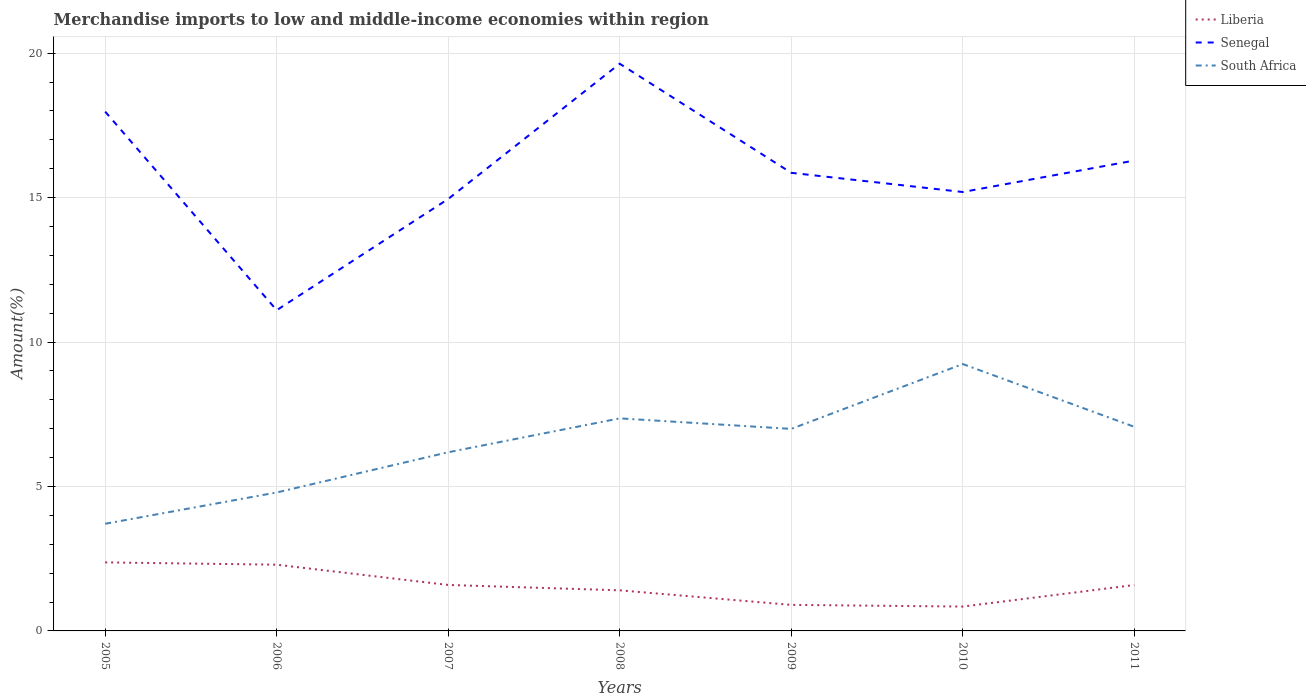Does the line corresponding to South Africa intersect with the line corresponding to Senegal?
Your response must be concise. No. Across all years, what is the maximum percentage of amount earned from merchandise imports in Liberia?
Your response must be concise. 0.84. In which year was the percentage of amount earned from merchandise imports in Liberia maximum?
Your answer should be very brief. 2010. What is the total percentage of amount earned from merchandise imports in South Africa in the graph?
Give a very brief answer. 0.36. What is the difference between the highest and the second highest percentage of amount earned from merchandise imports in Liberia?
Ensure brevity in your answer.  1.53. Is the percentage of amount earned from merchandise imports in South Africa strictly greater than the percentage of amount earned from merchandise imports in Senegal over the years?
Provide a short and direct response. Yes. How many lines are there?
Provide a succinct answer. 3. How many years are there in the graph?
Keep it short and to the point. 7. What is the difference between two consecutive major ticks on the Y-axis?
Your answer should be very brief. 5. Are the values on the major ticks of Y-axis written in scientific E-notation?
Offer a very short reply. No. How are the legend labels stacked?
Offer a very short reply. Vertical. What is the title of the graph?
Ensure brevity in your answer.  Merchandise imports to low and middle-income economies within region. Does "Pacific island small states" appear as one of the legend labels in the graph?
Your response must be concise. No. What is the label or title of the Y-axis?
Offer a terse response. Amount(%). What is the Amount(%) in Liberia in 2005?
Offer a terse response. 2.37. What is the Amount(%) in Senegal in 2005?
Keep it short and to the point. 17.98. What is the Amount(%) of South Africa in 2005?
Make the answer very short. 3.71. What is the Amount(%) in Liberia in 2006?
Ensure brevity in your answer.  2.29. What is the Amount(%) in Senegal in 2006?
Make the answer very short. 11.1. What is the Amount(%) of South Africa in 2006?
Keep it short and to the point. 4.79. What is the Amount(%) of Liberia in 2007?
Offer a very short reply. 1.59. What is the Amount(%) in Senegal in 2007?
Provide a short and direct response. 14.95. What is the Amount(%) of South Africa in 2007?
Make the answer very short. 6.19. What is the Amount(%) of Liberia in 2008?
Offer a very short reply. 1.41. What is the Amount(%) of Senegal in 2008?
Offer a terse response. 19.64. What is the Amount(%) in South Africa in 2008?
Offer a very short reply. 7.36. What is the Amount(%) in Liberia in 2009?
Your response must be concise. 0.9. What is the Amount(%) in Senegal in 2009?
Give a very brief answer. 15.86. What is the Amount(%) in South Africa in 2009?
Your answer should be very brief. 6.99. What is the Amount(%) in Liberia in 2010?
Make the answer very short. 0.84. What is the Amount(%) in Senegal in 2010?
Provide a short and direct response. 15.19. What is the Amount(%) in South Africa in 2010?
Provide a succinct answer. 9.24. What is the Amount(%) in Liberia in 2011?
Your response must be concise. 1.59. What is the Amount(%) in Senegal in 2011?
Keep it short and to the point. 16.28. What is the Amount(%) in South Africa in 2011?
Keep it short and to the point. 7.07. Across all years, what is the maximum Amount(%) in Liberia?
Offer a terse response. 2.37. Across all years, what is the maximum Amount(%) in Senegal?
Your response must be concise. 19.64. Across all years, what is the maximum Amount(%) of South Africa?
Ensure brevity in your answer.  9.24. Across all years, what is the minimum Amount(%) of Liberia?
Your response must be concise. 0.84. Across all years, what is the minimum Amount(%) in Senegal?
Offer a very short reply. 11.1. Across all years, what is the minimum Amount(%) of South Africa?
Provide a short and direct response. 3.71. What is the total Amount(%) of Liberia in the graph?
Ensure brevity in your answer.  11. What is the total Amount(%) in Senegal in the graph?
Ensure brevity in your answer.  111.01. What is the total Amount(%) in South Africa in the graph?
Make the answer very short. 45.35. What is the difference between the Amount(%) of Liberia in 2005 and that in 2006?
Offer a very short reply. 0.08. What is the difference between the Amount(%) in Senegal in 2005 and that in 2006?
Provide a succinct answer. 6.88. What is the difference between the Amount(%) in South Africa in 2005 and that in 2006?
Offer a terse response. -1.08. What is the difference between the Amount(%) of Liberia in 2005 and that in 2007?
Ensure brevity in your answer.  0.78. What is the difference between the Amount(%) of Senegal in 2005 and that in 2007?
Provide a succinct answer. 3.02. What is the difference between the Amount(%) of South Africa in 2005 and that in 2007?
Give a very brief answer. -2.48. What is the difference between the Amount(%) in Liberia in 2005 and that in 2008?
Give a very brief answer. 0.97. What is the difference between the Amount(%) of Senegal in 2005 and that in 2008?
Make the answer very short. -1.66. What is the difference between the Amount(%) of South Africa in 2005 and that in 2008?
Your answer should be compact. -3.65. What is the difference between the Amount(%) in Liberia in 2005 and that in 2009?
Ensure brevity in your answer.  1.47. What is the difference between the Amount(%) of Senegal in 2005 and that in 2009?
Offer a very short reply. 2.12. What is the difference between the Amount(%) of South Africa in 2005 and that in 2009?
Offer a very short reply. -3.28. What is the difference between the Amount(%) in Liberia in 2005 and that in 2010?
Ensure brevity in your answer.  1.53. What is the difference between the Amount(%) of Senegal in 2005 and that in 2010?
Offer a terse response. 2.78. What is the difference between the Amount(%) of South Africa in 2005 and that in 2010?
Ensure brevity in your answer.  -5.53. What is the difference between the Amount(%) in Liberia in 2005 and that in 2011?
Offer a very short reply. 0.78. What is the difference between the Amount(%) in Senegal in 2005 and that in 2011?
Your response must be concise. 1.69. What is the difference between the Amount(%) in South Africa in 2005 and that in 2011?
Give a very brief answer. -3.36. What is the difference between the Amount(%) in Liberia in 2006 and that in 2007?
Provide a succinct answer. 0.7. What is the difference between the Amount(%) of Senegal in 2006 and that in 2007?
Give a very brief answer. -3.85. What is the difference between the Amount(%) of South Africa in 2006 and that in 2007?
Keep it short and to the point. -1.39. What is the difference between the Amount(%) of Liberia in 2006 and that in 2008?
Your answer should be compact. 0.89. What is the difference between the Amount(%) in Senegal in 2006 and that in 2008?
Offer a very short reply. -8.53. What is the difference between the Amount(%) of South Africa in 2006 and that in 2008?
Your answer should be compact. -2.57. What is the difference between the Amount(%) of Liberia in 2006 and that in 2009?
Your answer should be very brief. 1.39. What is the difference between the Amount(%) in Senegal in 2006 and that in 2009?
Make the answer very short. -4.76. What is the difference between the Amount(%) of South Africa in 2006 and that in 2009?
Ensure brevity in your answer.  -2.2. What is the difference between the Amount(%) in Liberia in 2006 and that in 2010?
Offer a terse response. 1.45. What is the difference between the Amount(%) of Senegal in 2006 and that in 2010?
Offer a terse response. -4.09. What is the difference between the Amount(%) of South Africa in 2006 and that in 2010?
Make the answer very short. -4.45. What is the difference between the Amount(%) of Liberia in 2006 and that in 2011?
Give a very brief answer. 0.7. What is the difference between the Amount(%) of Senegal in 2006 and that in 2011?
Your answer should be very brief. -5.18. What is the difference between the Amount(%) in South Africa in 2006 and that in 2011?
Your answer should be very brief. -2.27. What is the difference between the Amount(%) in Liberia in 2007 and that in 2008?
Ensure brevity in your answer.  0.19. What is the difference between the Amount(%) in Senegal in 2007 and that in 2008?
Ensure brevity in your answer.  -4.68. What is the difference between the Amount(%) of South Africa in 2007 and that in 2008?
Keep it short and to the point. -1.17. What is the difference between the Amount(%) in Liberia in 2007 and that in 2009?
Offer a very short reply. 0.69. What is the difference between the Amount(%) of Senegal in 2007 and that in 2009?
Give a very brief answer. -0.91. What is the difference between the Amount(%) in South Africa in 2007 and that in 2009?
Ensure brevity in your answer.  -0.81. What is the difference between the Amount(%) in Liberia in 2007 and that in 2010?
Ensure brevity in your answer.  0.75. What is the difference between the Amount(%) in Senegal in 2007 and that in 2010?
Provide a short and direct response. -0.24. What is the difference between the Amount(%) of South Africa in 2007 and that in 2010?
Your answer should be compact. -3.05. What is the difference between the Amount(%) in Liberia in 2007 and that in 2011?
Your response must be concise. 0. What is the difference between the Amount(%) of Senegal in 2007 and that in 2011?
Your answer should be compact. -1.33. What is the difference between the Amount(%) in South Africa in 2007 and that in 2011?
Your response must be concise. -0.88. What is the difference between the Amount(%) of Liberia in 2008 and that in 2009?
Provide a short and direct response. 0.5. What is the difference between the Amount(%) of Senegal in 2008 and that in 2009?
Offer a terse response. 3.78. What is the difference between the Amount(%) of South Africa in 2008 and that in 2009?
Your answer should be very brief. 0.36. What is the difference between the Amount(%) in Liberia in 2008 and that in 2010?
Offer a very short reply. 0.56. What is the difference between the Amount(%) in Senegal in 2008 and that in 2010?
Offer a very short reply. 4.44. What is the difference between the Amount(%) in South Africa in 2008 and that in 2010?
Give a very brief answer. -1.88. What is the difference between the Amount(%) of Liberia in 2008 and that in 2011?
Keep it short and to the point. -0.18. What is the difference between the Amount(%) in Senegal in 2008 and that in 2011?
Give a very brief answer. 3.35. What is the difference between the Amount(%) in South Africa in 2008 and that in 2011?
Your response must be concise. 0.29. What is the difference between the Amount(%) of Liberia in 2009 and that in 2010?
Keep it short and to the point. 0.06. What is the difference between the Amount(%) in Senegal in 2009 and that in 2010?
Provide a succinct answer. 0.66. What is the difference between the Amount(%) in South Africa in 2009 and that in 2010?
Give a very brief answer. -2.25. What is the difference between the Amount(%) of Liberia in 2009 and that in 2011?
Keep it short and to the point. -0.69. What is the difference between the Amount(%) of Senegal in 2009 and that in 2011?
Your answer should be very brief. -0.42. What is the difference between the Amount(%) of South Africa in 2009 and that in 2011?
Make the answer very short. -0.07. What is the difference between the Amount(%) in Liberia in 2010 and that in 2011?
Ensure brevity in your answer.  -0.75. What is the difference between the Amount(%) of Senegal in 2010 and that in 2011?
Offer a terse response. -1.09. What is the difference between the Amount(%) of South Africa in 2010 and that in 2011?
Make the answer very short. 2.17. What is the difference between the Amount(%) of Liberia in 2005 and the Amount(%) of Senegal in 2006?
Your answer should be compact. -8.73. What is the difference between the Amount(%) of Liberia in 2005 and the Amount(%) of South Africa in 2006?
Ensure brevity in your answer.  -2.42. What is the difference between the Amount(%) in Senegal in 2005 and the Amount(%) in South Africa in 2006?
Provide a short and direct response. 13.19. What is the difference between the Amount(%) in Liberia in 2005 and the Amount(%) in Senegal in 2007?
Offer a very short reply. -12.58. What is the difference between the Amount(%) of Liberia in 2005 and the Amount(%) of South Africa in 2007?
Your response must be concise. -3.81. What is the difference between the Amount(%) in Senegal in 2005 and the Amount(%) in South Africa in 2007?
Your answer should be very brief. 11.79. What is the difference between the Amount(%) of Liberia in 2005 and the Amount(%) of Senegal in 2008?
Your response must be concise. -17.26. What is the difference between the Amount(%) in Liberia in 2005 and the Amount(%) in South Africa in 2008?
Your answer should be compact. -4.99. What is the difference between the Amount(%) in Senegal in 2005 and the Amount(%) in South Africa in 2008?
Make the answer very short. 10.62. What is the difference between the Amount(%) in Liberia in 2005 and the Amount(%) in Senegal in 2009?
Your response must be concise. -13.49. What is the difference between the Amount(%) in Liberia in 2005 and the Amount(%) in South Africa in 2009?
Offer a terse response. -4.62. What is the difference between the Amount(%) in Senegal in 2005 and the Amount(%) in South Africa in 2009?
Offer a terse response. 10.98. What is the difference between the Amount(%) of Liberia in 2005 and the Amount(%) of Senegal in 2010?
Make the answer very short. -12.82. What is the difference between the Amount(%) in Liberia in 2005 and the Amount(%) in South Africa in 2010?
Give a very brief answer. -6.87. What is the difference between the Amount(%) in Senegal in 2005 and the Amount(%) in South Africa in 2010?
Provide a succinct answer. 8.74. What is the difference between the Amount(%) of Liberia in 2005 and the Amount(%) of Senegal in 2011?
Make the answer very short. -13.91. What is the difference between the Amount(%) in Liberia in 2005 and the Amount(%) in South Africa in 2011?
Provide a short and direct response. -4.69. What is the difference between the Amount(%) of Senegal in 2005 and the Amount(%) of South Africa in 2011?
Provide a short and direct response. 10.91. What is the difference between the Amount(%) of Liberia in 2006 and the Amount(%) of Senegal in 2007?
Your answer should be very brief. -12.66. What is the difference between the Amount(%) in Liberia in 2006 and the Amount(%) in South Africa in 2007?
Make the answer very short. -3.89. What is the difference between the Amount(%) in Senegal in 2006 and the Amount(%) in South Africa in 2007?
Provide a succinct answer. 4.92. What is the difference between the Amount(%) in Liberia in 2006 and the Amount(%) in Senegal in 2008?
Offer a terse response. -17.34. What is the difference between the Amount(%) in Liberia in 2006 and the Amount(%) in South Africa in 2008?
Provide a short and direct response. -5.07. What is the difference between the Amount(%) in Senegal in 2006 and the Amount(%) in South Africa in 2008?
Offer a very short reply. 3.74. What is the difference between the Amount(%) in Liberia in 2006 and the Amount(%) in Senegal in 2009?
Provide a short and direct response. -13.57. What is the difference between the Amount(%) in Liberia in 2006 and the Amount(%) in South Africa in 2009?
Keep it short and to the point. -4.7. What is the difference between the Amount(%) in Senegal in 2006 and the Amount(%) in South Africa in 2009?
Your answer should be very brief. 4.11. What is the difference between the Amount(%) of Liberia in 2006 and the Amount(%) of Senegal in 2010?
Make the answer very short. -12.9. What is the difference between the Amount(%) in Liberia in 2006 and the Amount(%) in South Africa in 2010?
Ensure brevity in your answer.  -6.95. What is the difference between the Amount(%) of Senegal in 2006 and the Amount(%) of South Africa in 2010?
Keep it short and to the point. 1.86. What is the difference between the Amount(%) of Liberia in 2006 and the Amount(%) of Senegal in 2011?
Give a very brief answer. -13.99. What is the difference between the Amount(%) of Liberia in 2006 and the Amount(%) of South Africa in 2011?
Provide a succinct answer. -4.77. What is the difference between the Amount(%) in Senegal in 2006 and the Amount(%) in South Africa in 2011?
Provide a succinct answer. 4.04. What is the difference between the Amount(%) of Liberia in 2007 and the Amount(%) of Senegal in 2008?
Keep it short and to the point. -18.04. What is the difference between the Amount(%) of Liberia in 2007 and the Amount(%) of South Africa in 2008?
Your answer should be very brief. -5.77. What is the difference between the Amount(%) in Senegal in 2007 and the Amount(%) in South Africa in 2008?
Give a very brief answer. 7.59. What is the difference between the Amount(%) in Liberia in 2007 and the Amount(%) in Senegal in 2009?
Your response must be concise. -14.27. What is the difference between the Amount(%) of Liberia in 2007 and the Amount(%) of South Africa in 2009?
Keep it short and to the point. -5.4. What is the difference between the Amount(%) in Senegal in 2007 and the Amount(%) in South Africa in 2009?
Make the answer very short. 7.96. What is the difference between the Amount(%) of Liberia in 2007 and the Amount(%) of Senegal in 2010?
Your answer should be compact. -13.6. What is the difference between the Amount(%) in Liberia in 2007 and the Amount(%) in South Africa in 2010?
Your answer should be compact. -7.65. What is the difference between the Amount(%) of Senegal in 2007 and the Amount(%) of South Africa in 2010?
Give a very brief answer. 5.71. What is the difference between the Amount(%) of Liberia in 2007 and the Amount(%) of Senegal in 2011?
Give a very brief answer. -14.69. What is the difference between the Amount(%) in Liberia in 2007 and the Amount(%) in South Africa in 2011?
Provide a short and direct response. -5.48. What is the difference between the Amount(%) in Senegal in 2007 and the Amount(%) in South Africa in 2011?
Your answer should be very brief. 7.89. What is the difference between the Amount(%) of Liberia in 2008 and the Amount(%) of Senegal in 2009?
Provide a succinct answer. -14.45. What is the difference between the Amount(%) in Liberia in 2008 and the Amount(%) in South Africa in 2009?
Make the answer very short. -5.59. What is the difference between the Amount(%) of Senegal in 2008 and the Amount(%) of South Africa in 2009?
Offer a very short reply. 12.64. What is the difference between the Amount(%) of Liberia in 2008 and the Amount(%) of Senegal in 2010?
Provide a succinct answer. -13.79. What is the difference between the Amount(%) in Liberia in 2008 and the Amount(%) in South Africa in 2010?
Your answer should be very brief. -7.83. What is the difference between the Amount(%) in Senegal in 2008 and the Amount(%) in South Africa in 2010?
Provide a short and direct response. 10.4. What is the difference between the Amount(%) of Liberia in 2008 and the Amount(%) of Senegal in 2011?
Your answer should be compact. -14.88. What is the difference between the Amount(%) in Liberia in 2008 and the Amount(%) in South Africa in 2011?
Make the answer very short. -5.66. What is the difference between the Amount(%) of Senegal in 2008 and the Amount(%) of South Africa in 2011?
Make the answer very short. 12.57. What is the difference between the Amount(%) in Liberia in 2009 and the Amount(%) in Senegal in 2010?
Keep it short and to the point. -14.29. What is the difference between the Amount(%) of Liberia in 2009 and the Amount(%) of South Africa in 2010?
Provide a short and direct response. -8.34. What is the difference between the Amount(%) of Senegal in 2009 and the Amount(%) of South Africa in 2010?
Ensure brevity in your answer.  6.62. What is the difference between the Amount(%) of Liberia in 2009 and the Amount(%) of Senegal in 2011?
Offer a very short reply. -15.38. What is the difference between the Amount(%) in Liberia in 2009 and the Amount(%) in South Africa in 2011?
Your answer should be very brief. -6.17. What is the difference between the Amount(%) of Senegal in 2009 and the Amount(%) of South Africa in 2011?
Offer a very short reply. 8.79. What is the difference between the Amount(%) of Liberia in 2010 and the Amount(%) of Senegal in 2011?
Offer a very short reply. -15.44. What is the difference between the Amount(%) of Liberia in 2010 and the Amount(%) of South Africa in 2011?
Offer a terse response. -6.22. What is the difference between the Amount(%) in Senegal in 2010 and the Amount(%) in South Africa in 2011?
Offer a terse response. 8.13. What is the average Amount(%) of Liberia per year?
Make the answer very short. 1.57. What is the average Amount(%) of Senegal per year?
Make the answer very short. 15.86. What is the average Amount(%) in South Africa per year?
Your response must be concise. 6.48. In the year 2005, what is the difference between the Amount(%) in Liberia and Amount(%) in Senegal?
Your answer should be very brief. -15.61. In the year 2005, what is the difference between the Amount(%) in Liberia and Amount(%) in South Africa?
Offer a very short reply. -1.34. In the year 2005, what is the difference between the Amount(%) in Senegal and Amount(%) in South Africa?
Offer a very short reply. 14.27. In the year 2006, what is the difference between the Amount(%) of Liberia and Amount(%) of Senegal?
Offer a very short reply. -8.81. In the year 2006, what is the difference between the Amount(%) of Liberia and Amount(%) of South Africa?
Offer a very short reply. -2.5. In the year 2006, what is the difference between the Amount(%) in Senegal and Amount(%) in South Africa?
Your answer should be compact. 6.31. In the year 2007, what is the difference between the Amount(%) of Liberia and Amount(%) of Senegal?
Ensure brevity in your answer.  -13.36. In the year 2007, what is the difference between the Amount(%) in Liberia and Amount(%) in South Africa?
Your response must be concise. -4.59. In the year 2007, what is the difference between the Amount(%) in Senegal and Amount(%) in South Africa?
Provide a succinct answer. 8.77. In the year 2008, what is the difference between the Amount(%) in Liberia and Amount(%) in Senegal?
Offer a very short reply. -18.23. In the year 2008, what is the difference between the Amount(%) in Liberia and Amount(%) in South Africa?
Provide a short and direct response. -5.95. In the year 2008, what is the difference between the Amount(%) in Senegal and Amount(%) in South Africa?
Keep it short and to the point. 12.28. In the year 2009, what is the difference between the Amount(%) of Liberia and Amount(%) of Senegal?
Keep it short and to the point. -14.96. In the year 2009, what is the difference between the Amount(%) in Liberia and Amount(%) in South Africa?
Ensure brevity in your answer.  -6.09. In the year 2009, what is the difference between the Amount(%) in Senegal and Amount(%) in South Africa?
Your answer should be very brief. 8.87. In the year 2010, what is the difference between the Amount(%) in Liberia and Amount(%) in Senegal?
Make the answer very short. -14.35. In the year 2010, what is the difference between the Amount(%) of Liberia and Amount(%) of South Africa?
Your answer should be very brief. -8.4. In the year 2010, what is the difference between the Amount(%) of Senegal and Amount(%) of South Africa?
Keep it short and to the point. 5.96. In the year 2011, what is the difference between the Amount(%) of Liberia and Amount(%) of Senegal?
Your answer should be very brief. -14.69. In the year 2011, what is the difference between the Amount(%) of Liberia and Amount(%) of South Africa?
Make the answer very short. -5.48. In the year 2011, what is the difference between the Amount(%) of Senegal and Amount(%) of South Africa?
Give a very brief answer. 9.22. What is the ratio of the Amount(%) in Liberia in 2005 to that in 2006?
Give a very brief answer. 1.03. What is the ratio of the Amount(%) in Senegal in 2005 to that in 2006?
Give a very brief answer. 1.62. What is the ratio of the Amount(%) of South Africa in 2005 to that in 2006?
Ensure brevity in your answer.  0.77. What is the ratio of the Amount(%) of Liberia in 2005 to that in 2007?
Your answer should be compact. 1.49. What is the ratio of the Amount(%) in Senegal in 2005 to that in 2007?
Your response must be concise. 1.2. What is the ratio of the Amount(%) of South Africa in 2005 to that in 2007?
Give a very brief answer. 0.6. What is the ratio of the Amount(%) in Liberia in 2005 to that in 2008?
Provide a succinct answer. 1.69. What is the ratio of the Amount(%) in Senegal in 2005 to that in 2008?
Offer a very short reply. 0.92. What is the ratio of the Amount(%) in South Africa in 2005 to that in 2008?
Give a very brief answer. 0.5. What is the ratio of the Amount(%) in Liberia in 2005 to that in 2009?
Keep it short and to the point. 2.63. What is the ratio of the Amount(%) in Senegal in 2005 to that in 2009?
Your answer should be compact. 1.13. What is the ratio of the Amount(%) of South Africa in 2005 to that in 2009?
Your answer should be very brief. 0.53. What is the ratio of the Amount(%) in Liberia in 2005 to that in 2010?
Provide a succinct answer. 2.81. What is the ratio of the Amount(%) in Senegal in 2005 to that in 2010?
Keep it short and to the point. 1.18. What is the ratio of the Amount(%) of South Africa in 2005 to that in 2010?
Give a very brief answer. 0.4. What is the ratio of the Amount(%) in Liberia in 2005 to that in 2011?
Your answer should be compact. 1.49. What is the ratio of the Amount(%) of Senegal in 2005 to that in 2011?
Your response must be concise. 1.1. What is the ratio of the Amount(%) in South Africa in 2005 to that in 2011?
Keep it short and to the point. 0.52. What is the ratio of the Amount(%) of Liberia in 2006 to that in 2007?
Make the answer very short. 1.44. What is the ratio of the Amount(%) of Senegal in 2006 to that in 2007?
Offer a terse response. 0.74. What is the ratio of the Amount(%) of South Africa in 2006 to that in 2007?
Provide a succinct answer. 0.77. What is the ratio of the Amount(%) of Liberia in 2006 to that in 2008?
Provide a succinct answer. 1.63. What is the ratio of the Amount(%) in Senegal in 2006 to that in 2008?
Ensure brevity in your answer.  0.57. What is the ratio of the Amount(%) in South Africa in 2006 to that in 2008?
Provide a succinct answer. 0.65. What is the ratio of the Amount(%) in Liberia in 2006 to that in 2009?
Ensure brevity in your answer.  2.54. What is the ratio of the Amount(%) of Senegal in 2006 to that in 2009?
Ensure brevity in your answer.  0.7. What is the ratio of the Amount(%) of South Africa in 2006 to that in 2009?
Ensure brevity in your answer.  0.69. What is the ratio of the Amount(%) in Liberia in 2006 to that in 2010?
Offer a very short reply. 2.72. What is the ratio of the Amount(%) of Senegal in 2006 to that in 2010?
Your answer should be compact. 0.73. What is the ratio of the Amount(%) in South Africa in 2006 to that in 2010?
Provide a succinct answer. 0.52. What is the ratio of the Amount(%) in Liberia in 2006 to that in 2011?
Your response must be concise. 1.44. What is the ratio of the Amount(%) of Senegal in 2006 to that in 2011?
Give a very brief answer. 0.68. What is the ratio of the Amount(%) of South Africa in 2006 to that in 2011?
Offer a very short reply. 0.68. What is the ratio of the Amount(%) in Liberia in 2007 to that in 2008?
Keep it short and to the point. 1.13. What is the ratio of the Amount(%) of Senegal in 2007 to that in 2008?
Offer a very short reply. 0.76. What is the ratio of the Amount(%) of South Africa in 2007 to that in 2008?
Your response must be concise. 0.84. What is the ratio of the Amount(%) in Liberia in 2007 to that in 2009?
Your answer should be compact. 1.76. What is the ratio of the Amount(%) in Senegal in 2007 to that in 2009?
Give a very brief answer. 0.94. What is the ratio of the Amount(%) in South Africa in 2007 to that in 2009?
Offer a terse response. 0.88. What is the ratio of the Amount(%) of Liberia in 2007 to that in 2010?
Your answer should be very brief. 1.89. What is the ratio of the Amount(%) in Senegal in 2007 to that in 2010?
Provide a succinct answer. 0.98. What is the ratio of the Amount(%) of South Africa in 2007 to that in 2010?
Your answer should be very brief. 0.67. What is the ratio of the Amount(%) of Liberia in 2007 to that in 2011?
Your answer should be very brief. 1. What is the ratio of the Amount(%) in Senegal in 2007 to that in 2011?
Offer a very short reply. 0.92. What is the ratio of the Amount(%) of South Africa in 2007 to that in 2011?
Ensure brevity in your answer.  0.88. What is the ratio of the Amount(%) in Liberia in 2008 to that in 2009?
Your answer should be compact. 1.56. What is the ratio of the Amount(%) in Senegal in 2008 to that in 2009?
Make the answer very short. 1.24. What is the ratio of the Amount(%) in South Africa in 2008 to that in 2009?
Make the answer very short. 1.05. What is the ratio of the Amount(%) in Liberia in 2008 to that in 2010?
Ensure brevity in your answer.  1.67. What is the ratio of the Amount(%) of Senegal in 2008 to that in 2010?
Provide a succinct answer. 1.29. What is the ratio of the Amount(%) in South Africa in 2008 to that in 2010?
Your answer should be very brief. 0.8. What is the ratio of the Amount(%) of Liberia in 2008 to that in 2011?
Give a very brief answer. 0.88. What is the ratio of the Amount(%) in Senegal in 2008 to that in 2011?
Your answer should be compact. 1.21. What is the ratio of the Amount(%) of South Africa in 2008 to that in 2011?
Your response must be concise. 1.04. What is the ratio of the Amount(%) in Liberia in 2009 to that in 2010?
Your answer should be very brief. 1.07. What is the ratio of the Amount(%) of Senegal in 2009 to that in 2010?
Make the answer very short. 1.04. What is the ratio of the Amount(%) in South Africa in 2009 to that in 2010?
Your answer should be compact. 0.76. What is the ratio of the Amount(%) in Liberia in 2009 to that in 2011?
Offer a very short reply. 0.57. What is the ratio of the Amount(%) of Liberia in 2010 to that in 2011?
Your answer should be very brief. 0.53. What is the ratio of the Amount(%) of Senegal in 2010 to that in 2011?
Keep it short and to the point. 0.93. What is the ratio of the Amount(%) in South Africa in 2010 to that in 2011?
Provide a short and direct response. 1.31. What is the difference between the highest and the second highest Amount(%) of Liberia?
Offer a terse response. 0.08. What is the difference between the highest and the second highest Amount(%) of Senegal?
Offer a very short reply. 1.66. What is the difference between the highest and the second highest Amount(%) of South Africa?
Offer a very short reply. 1.88. What is the difference between the highest and the lowest Amount(%) in Liberia?
Your answer should be compact. 1.53. What is the difference between the highest and the lowest Amount(%) of Senegal?
Your response must be concise. 8.53. What is the difference between the highest and the lowest Amount(%) in South Africa?
Provide a succinct answer. 5.53. 